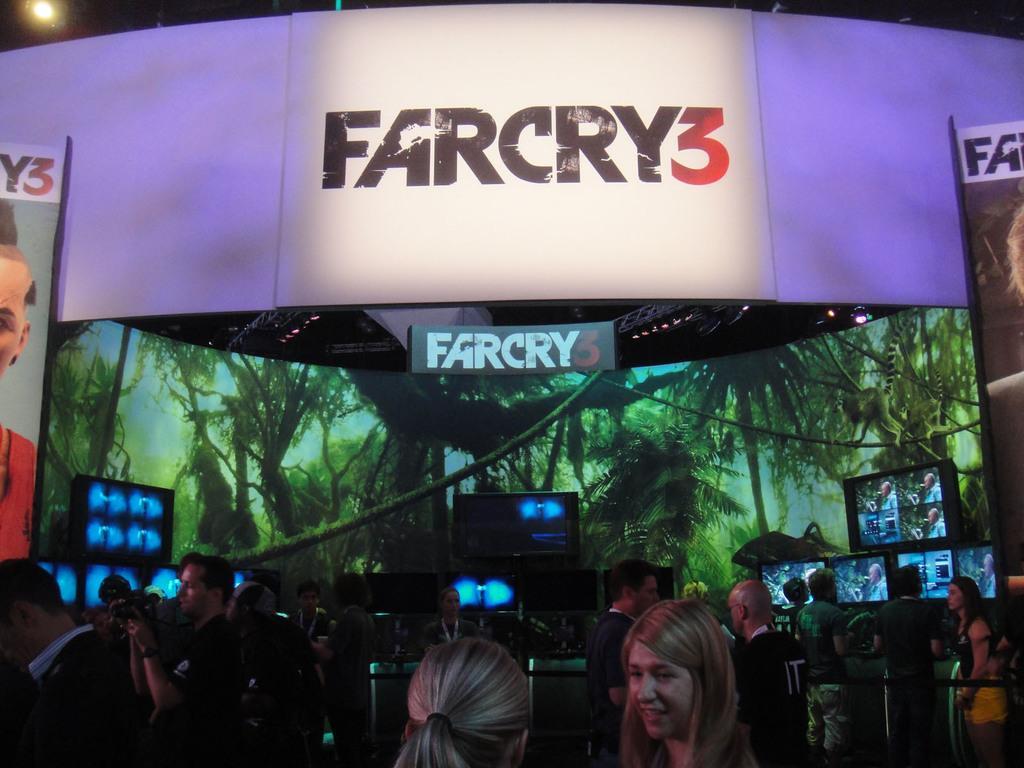How would you summarize this image in a sentence or two? In this image I can see group of people standing. Also there are screens and boards. 